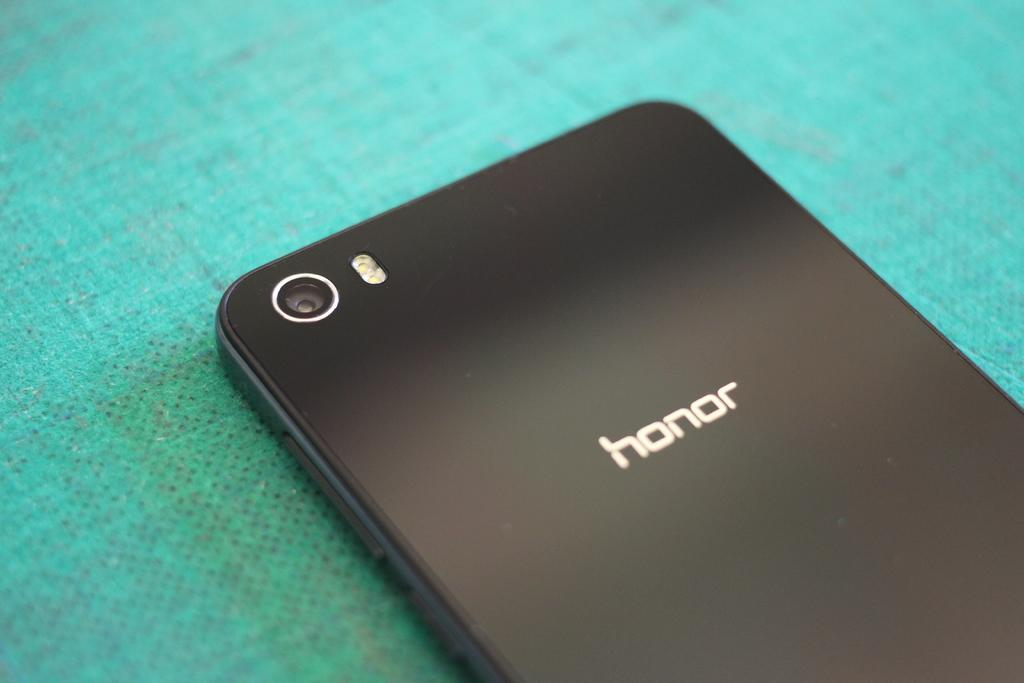Provide a one-sentence caption for the provided image. A honor cell phone sits backside up on a teal table cloth. 